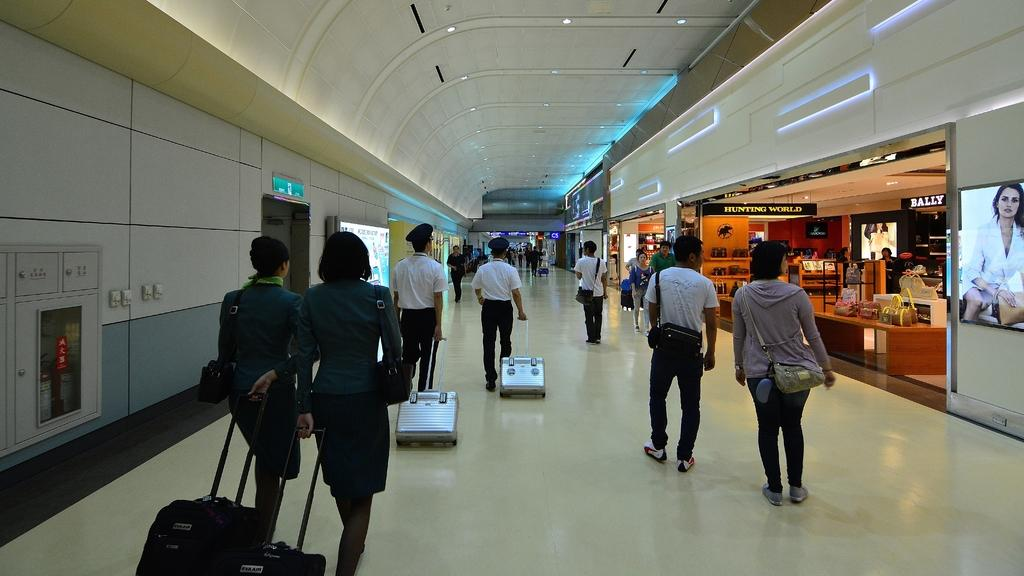What are the people in the image doing? The people in the image are walking. What are the people carrying while walking? The people are walking with trolleys. What type of location is depicted in the image? The location appears to be an airport. What can be seen in the background of the image? There is a shopping store visible in the background. How many family members are present in the image? The provided facts do not mention any family members, so it cannot be determined from the image. What territory is being claimed by the people in the image? There is no indication in the image that the people are claiming any territory. 